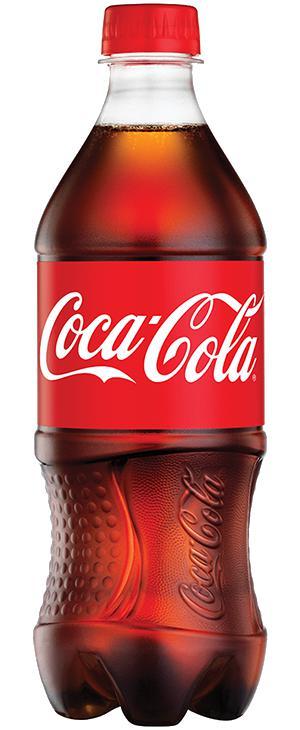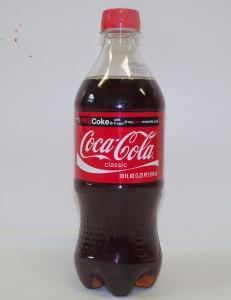The first image is the image on the left, the second image is the image on the right. Examine the images to the left and right. Is the description "Only plastic, filled soda bottles with lids and labels are shown, and the left image features at least one bottle with a semi-hourglass shape, while the right image shows three bottles with different labels." accurate? Answer yes or no. No. The first image is the image on the left, the second image is the image on the right. For the images shown, is this caption "In the right image, there is a green colored plastic soda bottle" true? Answer yes or no. No. 